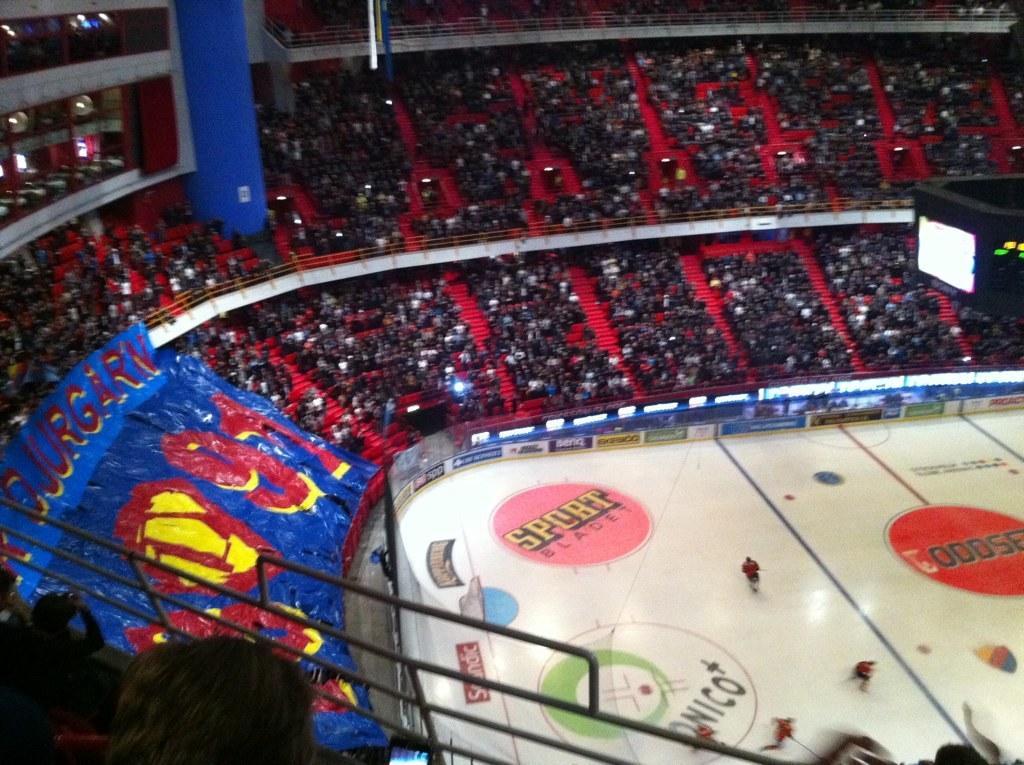In one or two sentences, can you explain what this image depicts? This image is taken in a stadium. In this image we can see some players playing. We can also see many people sitting in the stands. The image also consists of a painting with a logo and number and also the text. We can also see the screen and also the fence. 